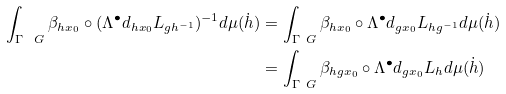Convert formula to latex. <formula><loc_0><loc_0><loc_500><loc_500>\int _ { \Gamma \ G } \beta _ { h x _ { 0 } } \circ ( \Lambda ^ { \bullet } d _ { h x _ { 0 } } L _ { g h ^ { - 1 } } ) ^ { - 1 } d \mu ( \dot { h } ) & = \int _ { \Gamma \ G } \beta _ { h x _ { 0 } } \circ \Lambda ^ { \bullet } d _ { g x _ { 0 } } L _ { h g ^ { - 1 } } d \mu ( \dot { h } ) \\ & = \int _ { \Gamma \ G } \beta _ { h g x _ { 0 } } \circ \Lambda ^ { \bullet } d _ { g x _ { 0 } } L _ { h } d \mu ( \dot { h } )</formula> 